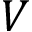<formula> <loc_0><loc_0><loc_500><loc_500>V</formula> 